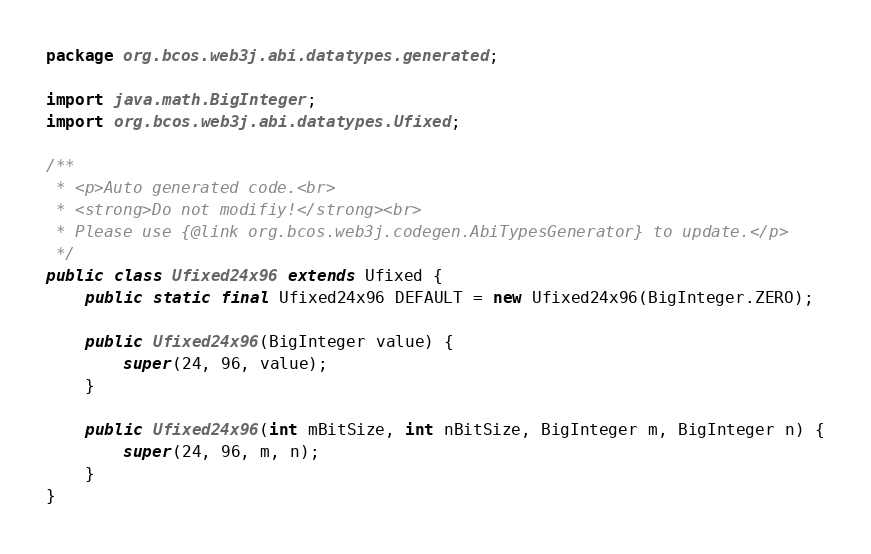<code> <loc_0><loc_0><loc_500><loc_500><_Java_>package org.bcos.web3j.abi.datatypes.generated;

import java.math.BigInteger;
import org.bcos.web3j.abi.datatypes.Ufixed;

/**
 * <p>Auto generated code.<br>
 * <strong>Do not modifiy!</strong><br>
 * Please use {@link org.bcos.web3j.codegen.AbiTypesGenerator} to update.</p>
 */
public class Ufixed24x96 extends Ufixed {
    public static final Ufixed24x96 DEFAULT = new Ufixed24x96(BigInteger.ZERO);

    public Ufixed24x96(BigInteger value) {
        super(24, 96, value);
    }

    public Ufixed24x96(int mBitSize, int nBitSize, BigInteger m, BigInteger n) {
        super(24, 96, m, n);
    }
}
</code> 